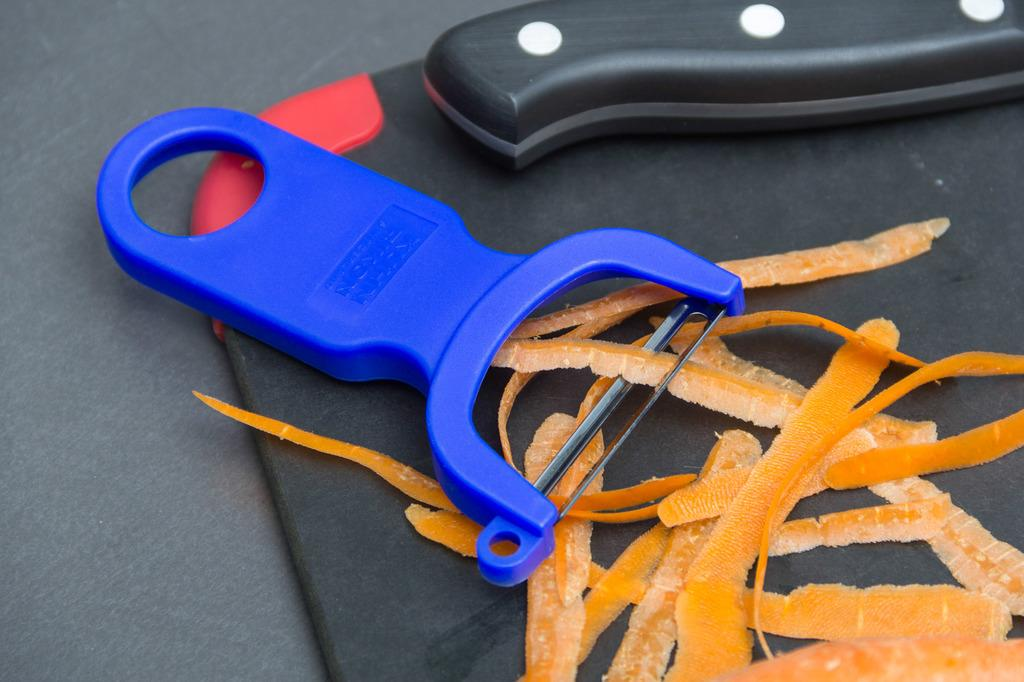What type of food can be seen in the image? There are carrot pieces in the image. What tool is present in the image that could be used to cut the carrot pieces? There is a knife in the image. What other tool is present in the image that could be used to cut the carrot pieces? There is a slicer in the image. On what surface are the carrot pieces, knife, and slicer placed? The objects are on a black surface, which is likely a table. What type of trousers can be seen hanging from the slicer in the image? There are no trousers present in the image, and the slicer is not being used to hang any clothing items. 